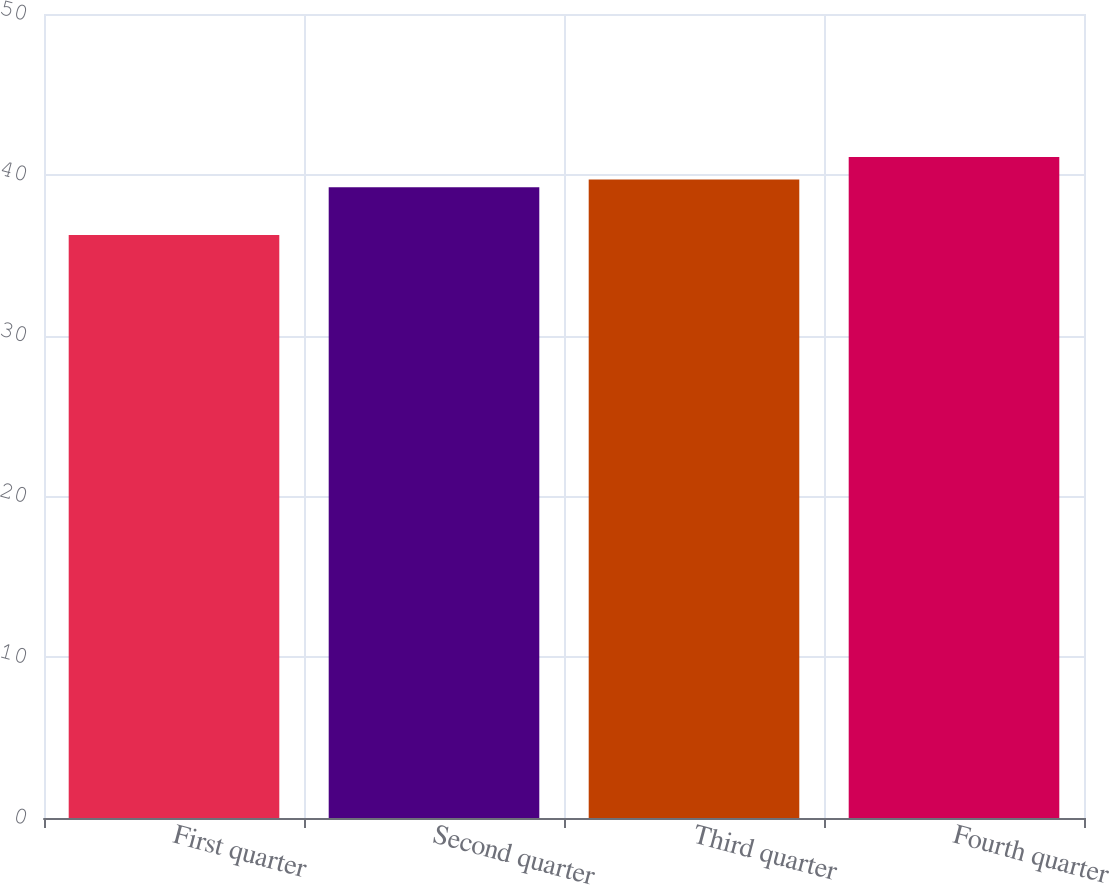Convert chart. <chart><loc_0><loc_0><loc_500><loc_500><bar_chart><fcel>First quarter<fcel>Second quarter<fcel>Third quarter<fcel>Fourth quarter<nl><fcel>36.26<fcel>39.23<fcel>39.71<fcel>41.11<nl></chart> 